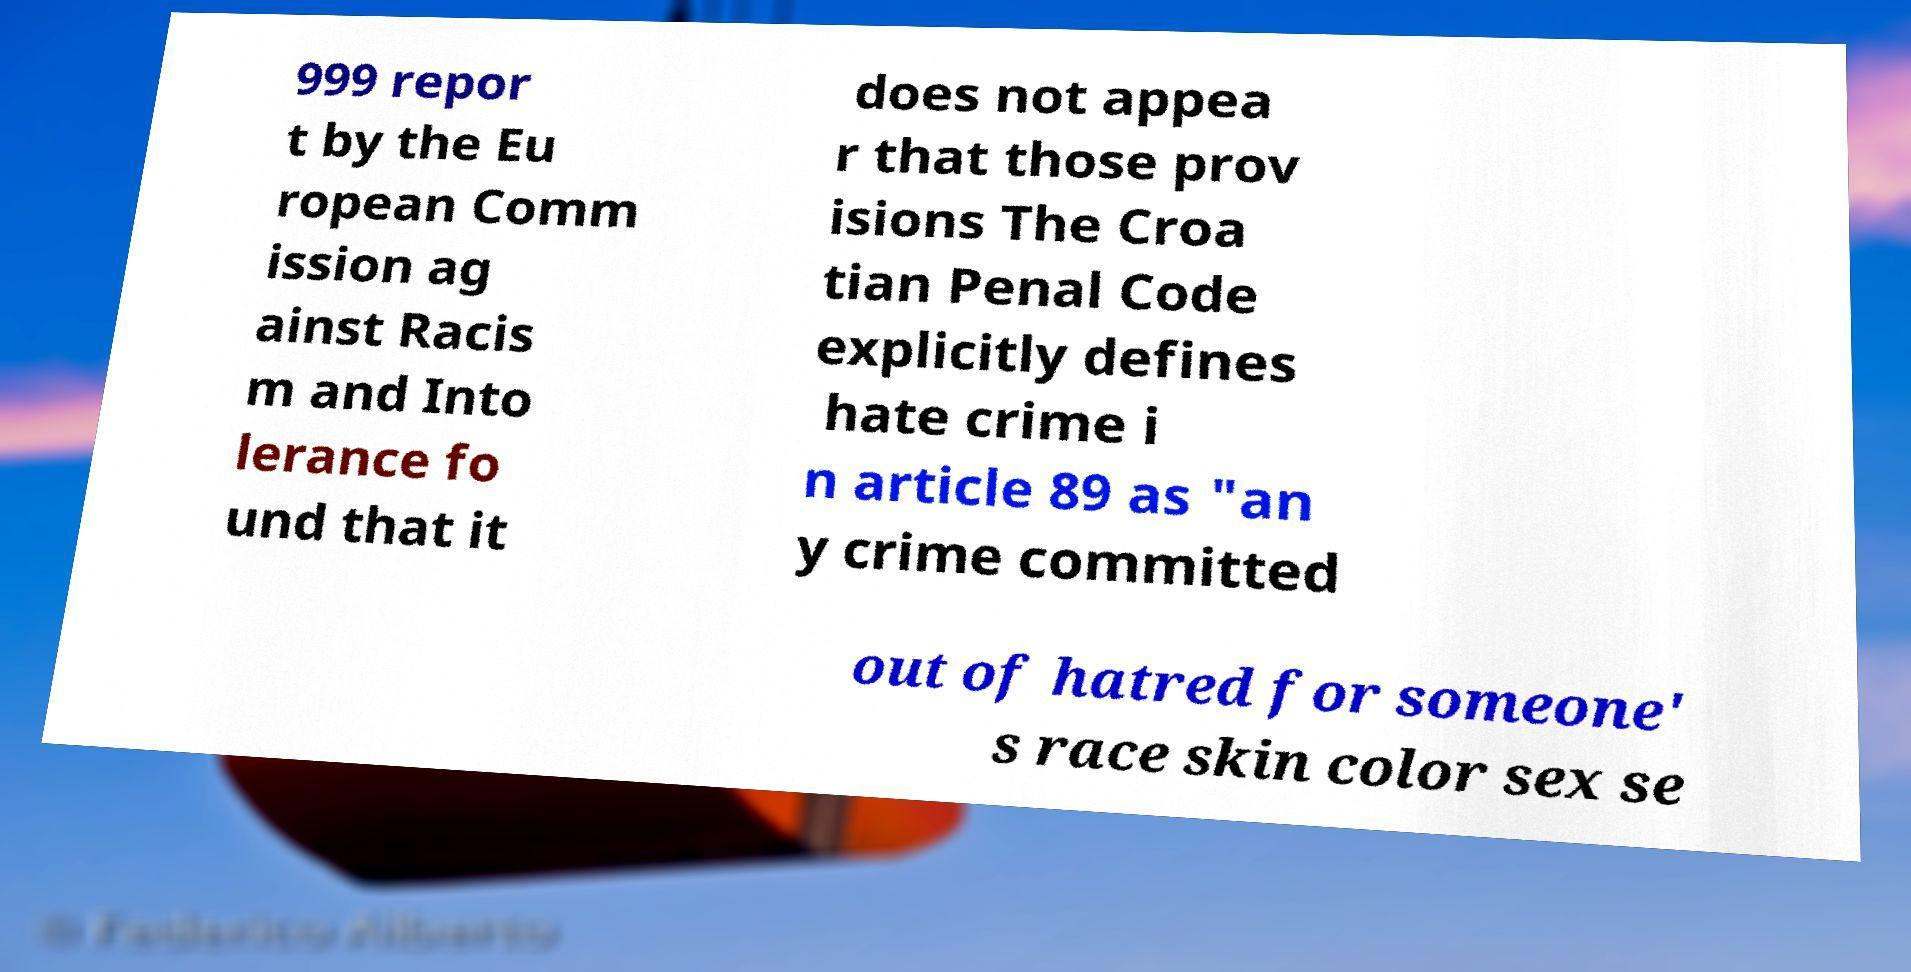I need the written content from this picture converted into text. Can you do that? 999 repor t by the Eu ropean Comm ission ag ainst Racis m and Into lerance fo und that it does not appea r that those prov isions The Croa tian Penal Code explicitly defines hate crime i n article 89 as "an y crime committed out of hatred for someone' s race skin color sex se 